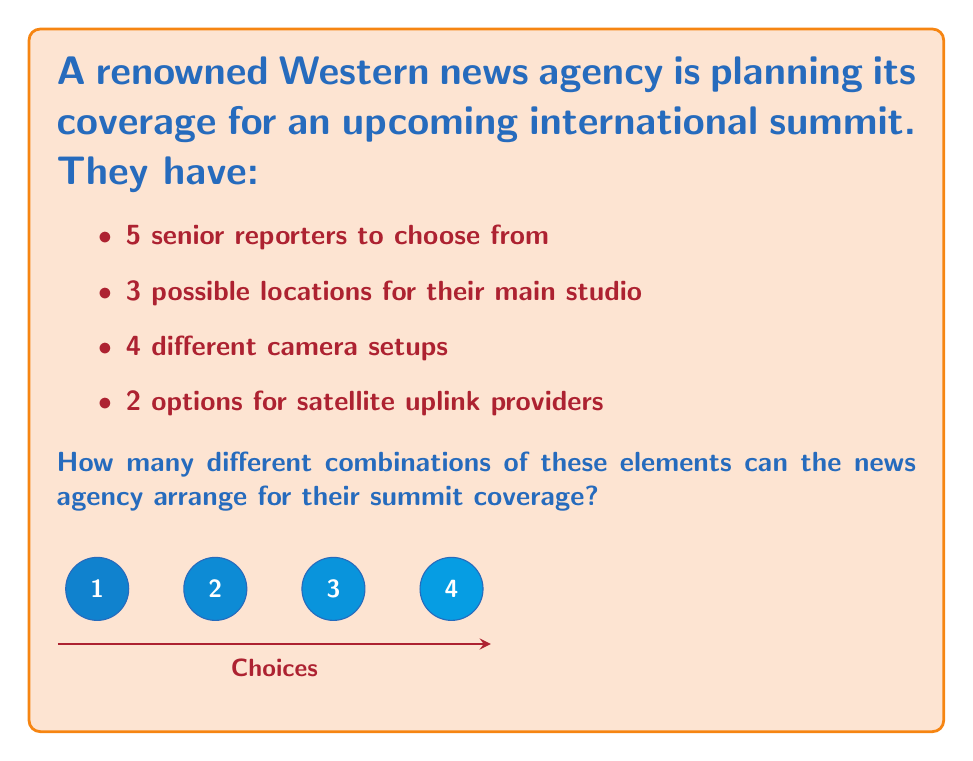Give your solution to this math problem. To solve this problem, we'll use the multiplication principle of counting. This principle states that if we have a series of independent choices, the total number of possible outcomes is the product of the number of options for each choice.

Let's break down the choices:
1. Senior reporters: 5 options
2. Studio locations: 3 options
3. Camera setups: 4 options
4. Satellite uplink providers: 2 options

Now, we multiply these numbers together:

$$ \text{Total combinations} = 5 \times 3 \times 4 \times 2 $$

$$ = 120 $$

This calculation gives us the total number of possible unique arrangements for the news agency's summit coverage.

To understand why this works, consider that for each reporter (5 choices), we have 3 possible studio locations. This gives us $5 \times 3 = 15$ reporter-studio combinations. For each of these 15 combinations, we have 4 camera setup options, resulting in $15 \times 4 = 60$ reporter-studio-camera combinations. Finally, for each of these 60 combinations, we have 2 uplink provider options, leading to our final result of $60 \times 2 = 120$ total possible combinations.
Answer: 120 combinations 